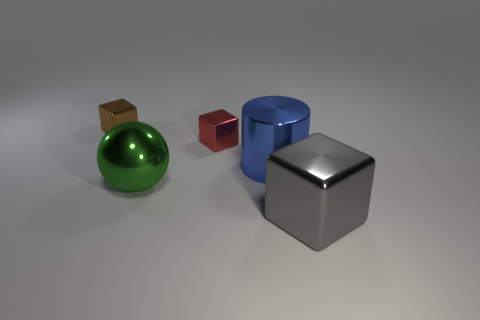Subtract all tiny metal blocks. How many blocks are left? 1 Add 4 gray shiny blocks. How many objects exist? 9 Subtract 1 gray blocks. How many objects are left? 4 Subtract all cubes. How many objects are left? 2 Subtract all blue balls. Subtract all purple cylinders. How many balls are left? 1 Subtract all red cubes. How many yellow cylinders are left? 0 Subtract all big brown metallic cylinders. Subtract all small metal cubes. How many objects are left? 3 Add 4 shiny cylinders. How many shiny cylinders are left? 5 Add 5 gray shiny things. How many gray shiny things exist? 6 